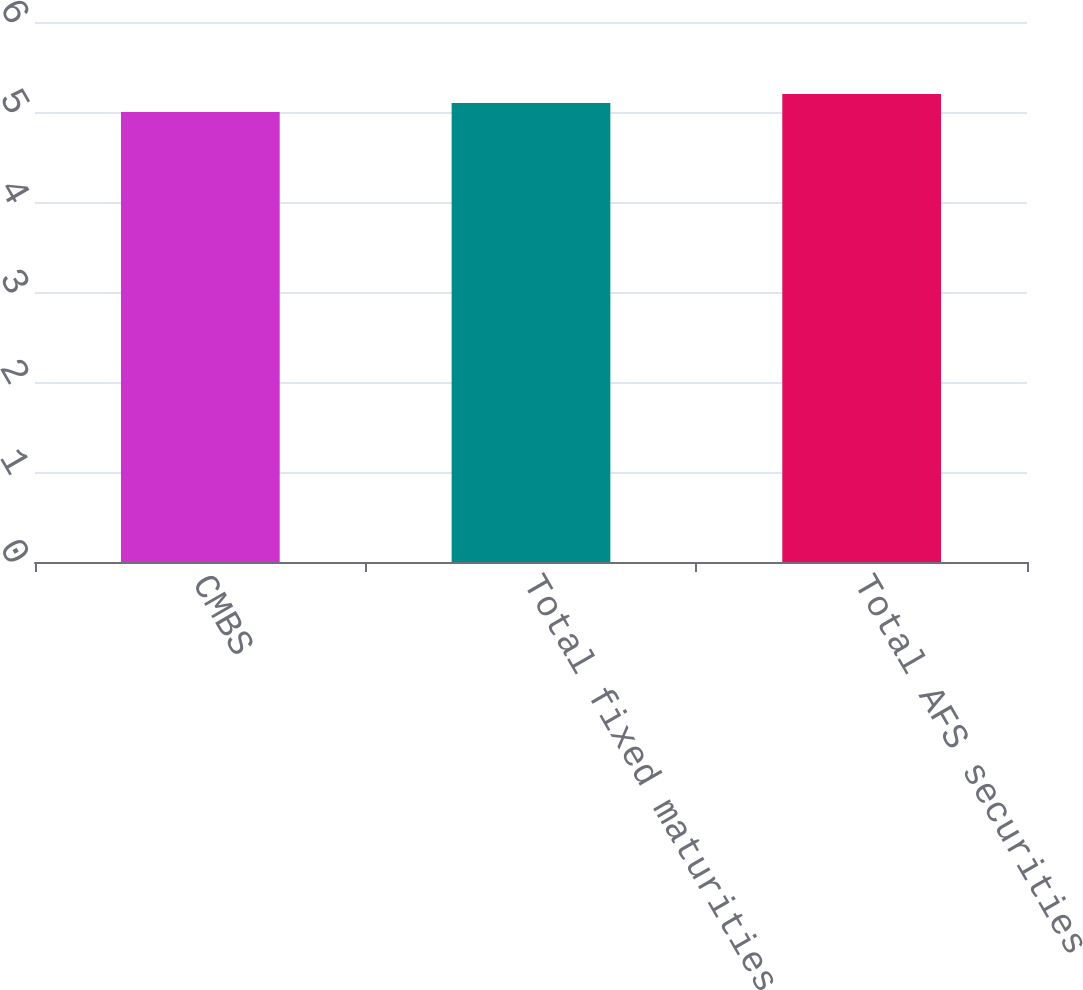<chart> <loc_0><loc_0><loc_500><loc_500><bar_chart><fcel>CMBS<fcel>Total fixed maturities AFS<fcel>Total AFS securities<nl><fcel>5<fcel>5.1<fcel>5.2<nl></chart> 